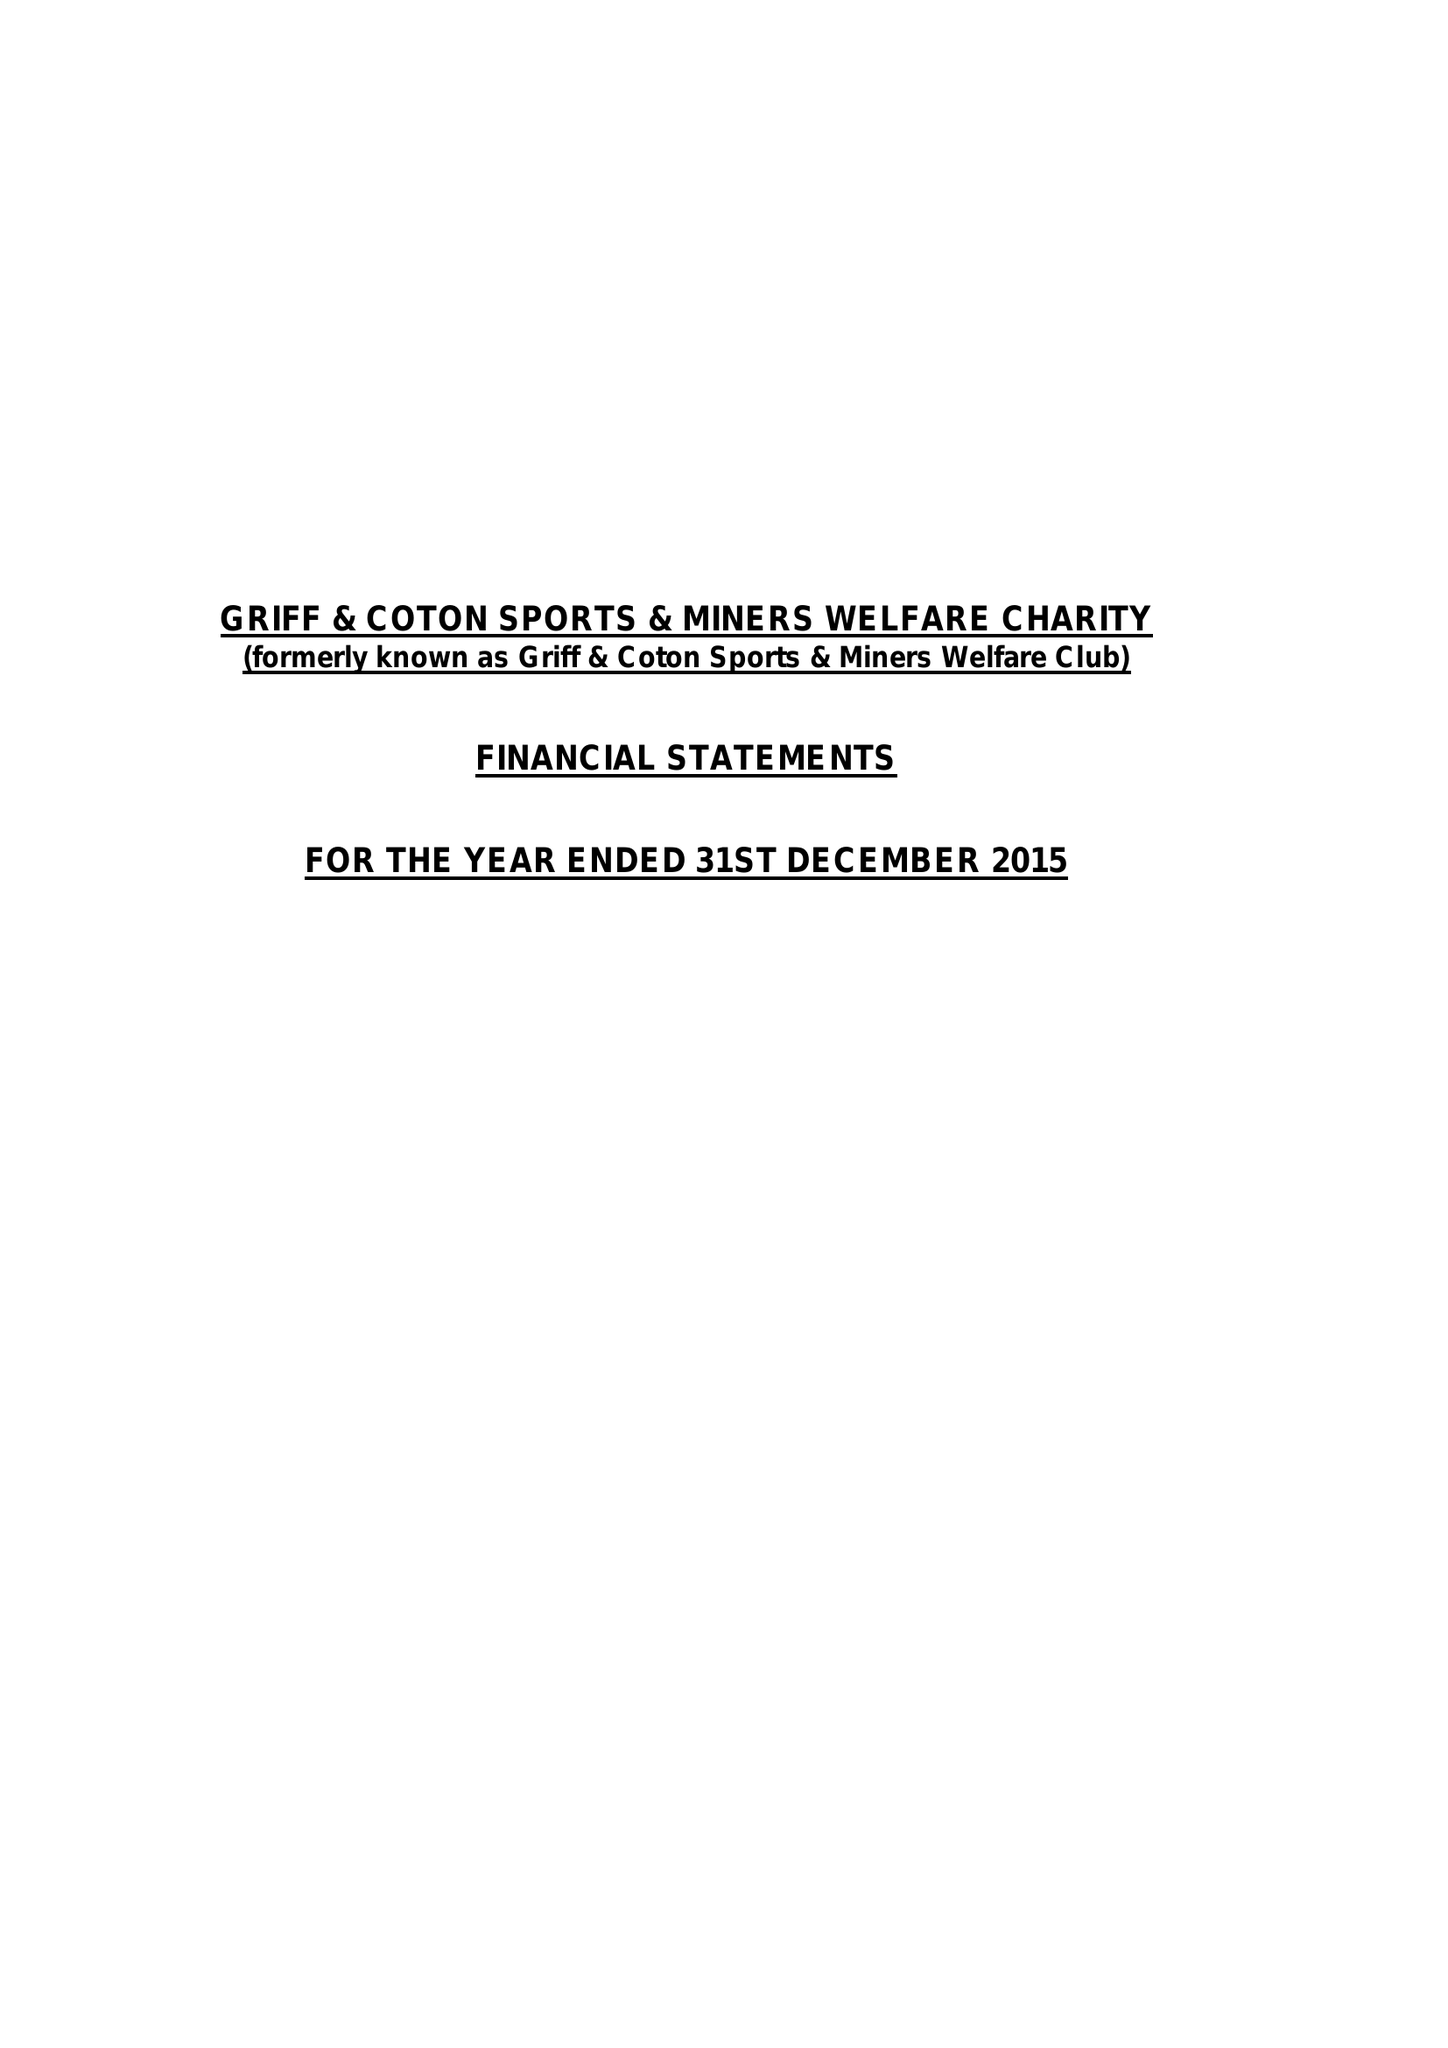What is the value for the address__street_line?
Answer the question using a single word or phrase. HEATH END ROAD 